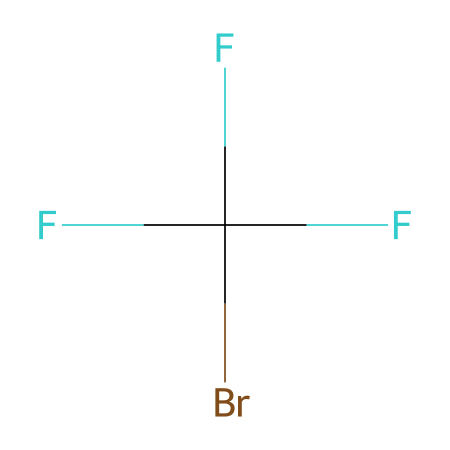What is the molecular formula of Halon 1301? The SMILES representation indicates the presence of one carbon atom (C), three fluorine atoms (F), and one bromine atom (Br). Thus, the molecular formula can be derived as CBrF3.
Answer: CBrF3 How many fluorine atoms are present in Halon 1301? The SMILES representation shows that there are three fluorine atoms (F), which can be directly counted from the notation.
Answer: 3 What type of bonds are present in Halon 1301? In Halon 1301, there are single bonds between carbon and fluorine and between carbon and bromine, as indicated by the lack of any symbols for double or triple bonds in the SMILES.
Answer: single bonds What is the central atom of Halon 1301? The structure contains a single carbon atom that is the central atom, surrounded by three fluorine atoms and one bromine atom, making it the core element.
Answer: carbon What role does bromine play in Halon 1301? Bromine is known to be effective in interrupting combustion reactions, acting as the primary agent for fire suppression in this chemical, as inferred from its presence in the structure.
Answer: fire suppression Why is Halon 1301 categorized as a refrigerant? Halon 1301's properties allow it to absorb heat during chemical reactions, making it suitable for refrigeration applications, as seen from its capability to function as a fire suppression agent.
Answer: refrigeration What is the main use of Halon 1301? Halon 1301 is primarily used as a fire suppression agent, particularly in aircraft systems, due to its effective fire-extinguishing properties as indicated by its chemical functionality.
Answer: fire suppression agent 